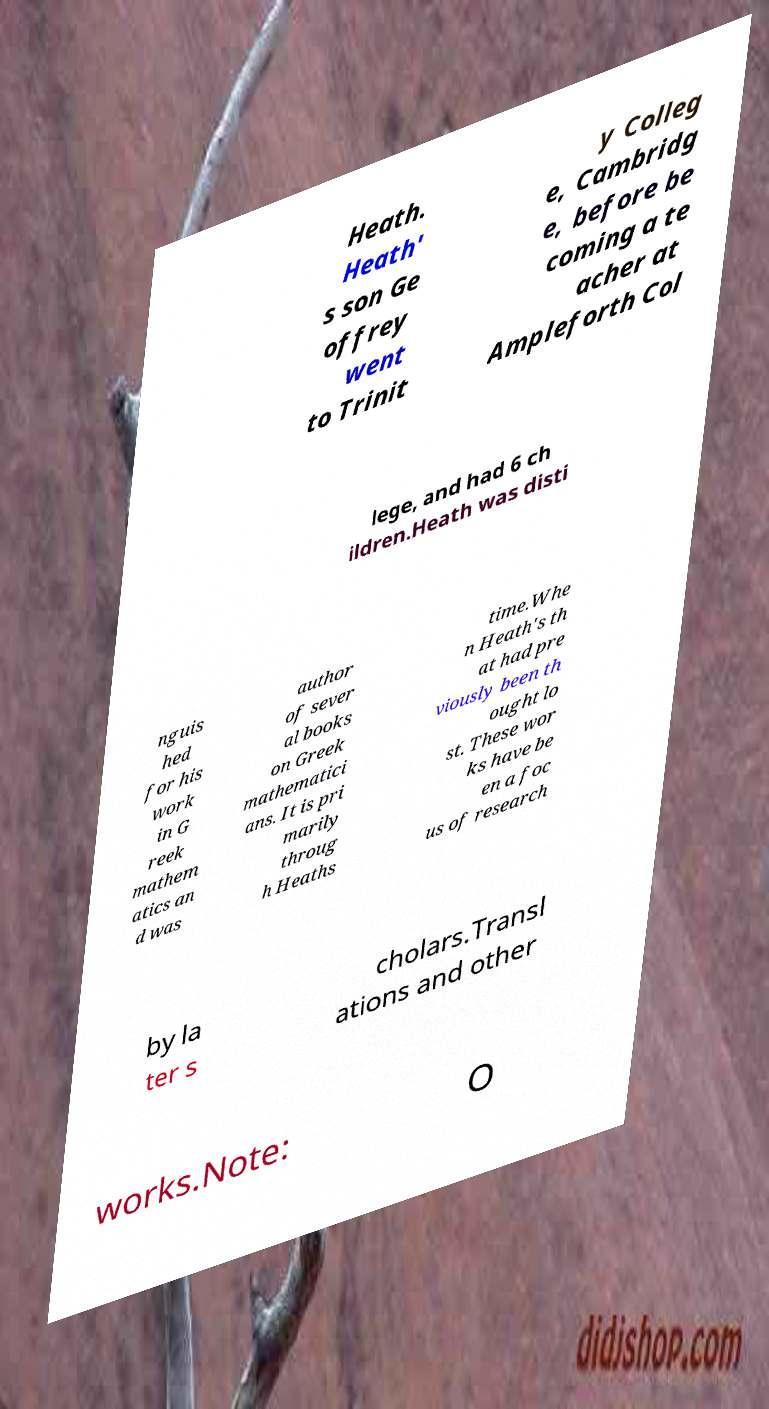There's text embedded in this image that I need extracted. Can you transcribe it verbatim? Heath. Heath' s son Ge offrey went to Trinit y Colleg e, Cambridg e, before be coming a te acher at Ampleforth Col lege, and had 6 ch ildren.Heath was disti nguis hed for his work in G reek mathem atics an d was author of sever al books on Greek mathematici ans. It is pri marily throug h Heaths time.Whe n Heath's th at had pre viously been th ought lo st. These wor ks have be en a foc us of research by la ter s cholars.Transl ations and other works.Note: O 